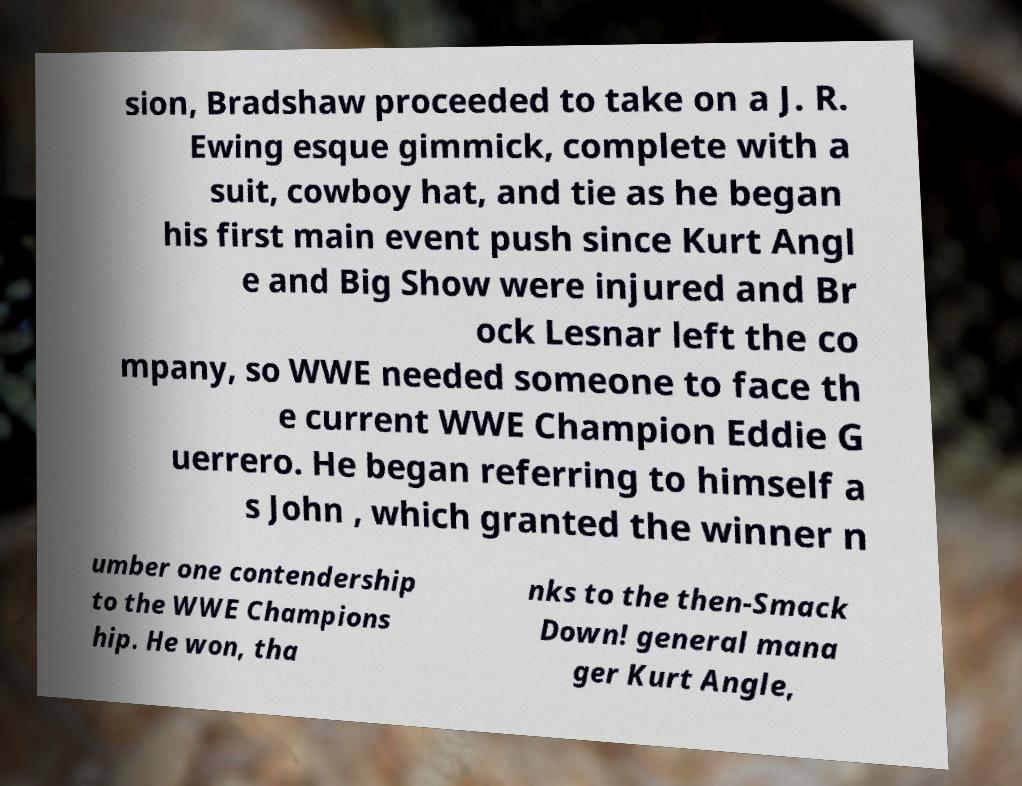For documentation purposes, I need the text within this image transcribed. Could you provide that? sion, Bradshaw proceeded to take on a J. R. Ewing esque gimmick, complete with a suit, cowboy hat, and tie as he began his first main event push since Kurt Angl e and Big Show were injured and Br ock Lesnar left the co mpany, so WWE needed someone to face th e current WWE Champion Eddie G uerrero. He began referring to himself a s John , which granted the winner n umber one contendership to the WWE Champions hip. He won, tha nks to the then-Smack Down! general mana ger Kurt Angle, 